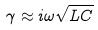<formula> <loc_0><loc_0><loc_500><loc_500>\gamma \approx i \omega \sqrt { L C }</formula> 